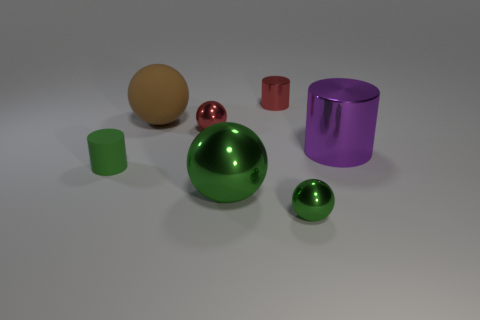Subtract all shiny cylinders. How many cylinders are left? 1 Subtract all red balls. How many balls are left? 3 Subtract all cyan cubes. How many green spheres are left? 2 Subtract all balls. How many objects are left? 3 Subtract 1 cylinders. How many cylinders are left? 2 Add 1 red metal spheres. How many objects exist? 8 Subtract all small blue spheres. Subtract all brown balls. How many objects are left? 6 Add 7 small metallic cylinders. How many small metallic cylinders are left? 8 Add 1 tiny red things. How many tiny red things exist? 3 Subtract 0 gray blocks. How many objects are left? 7 